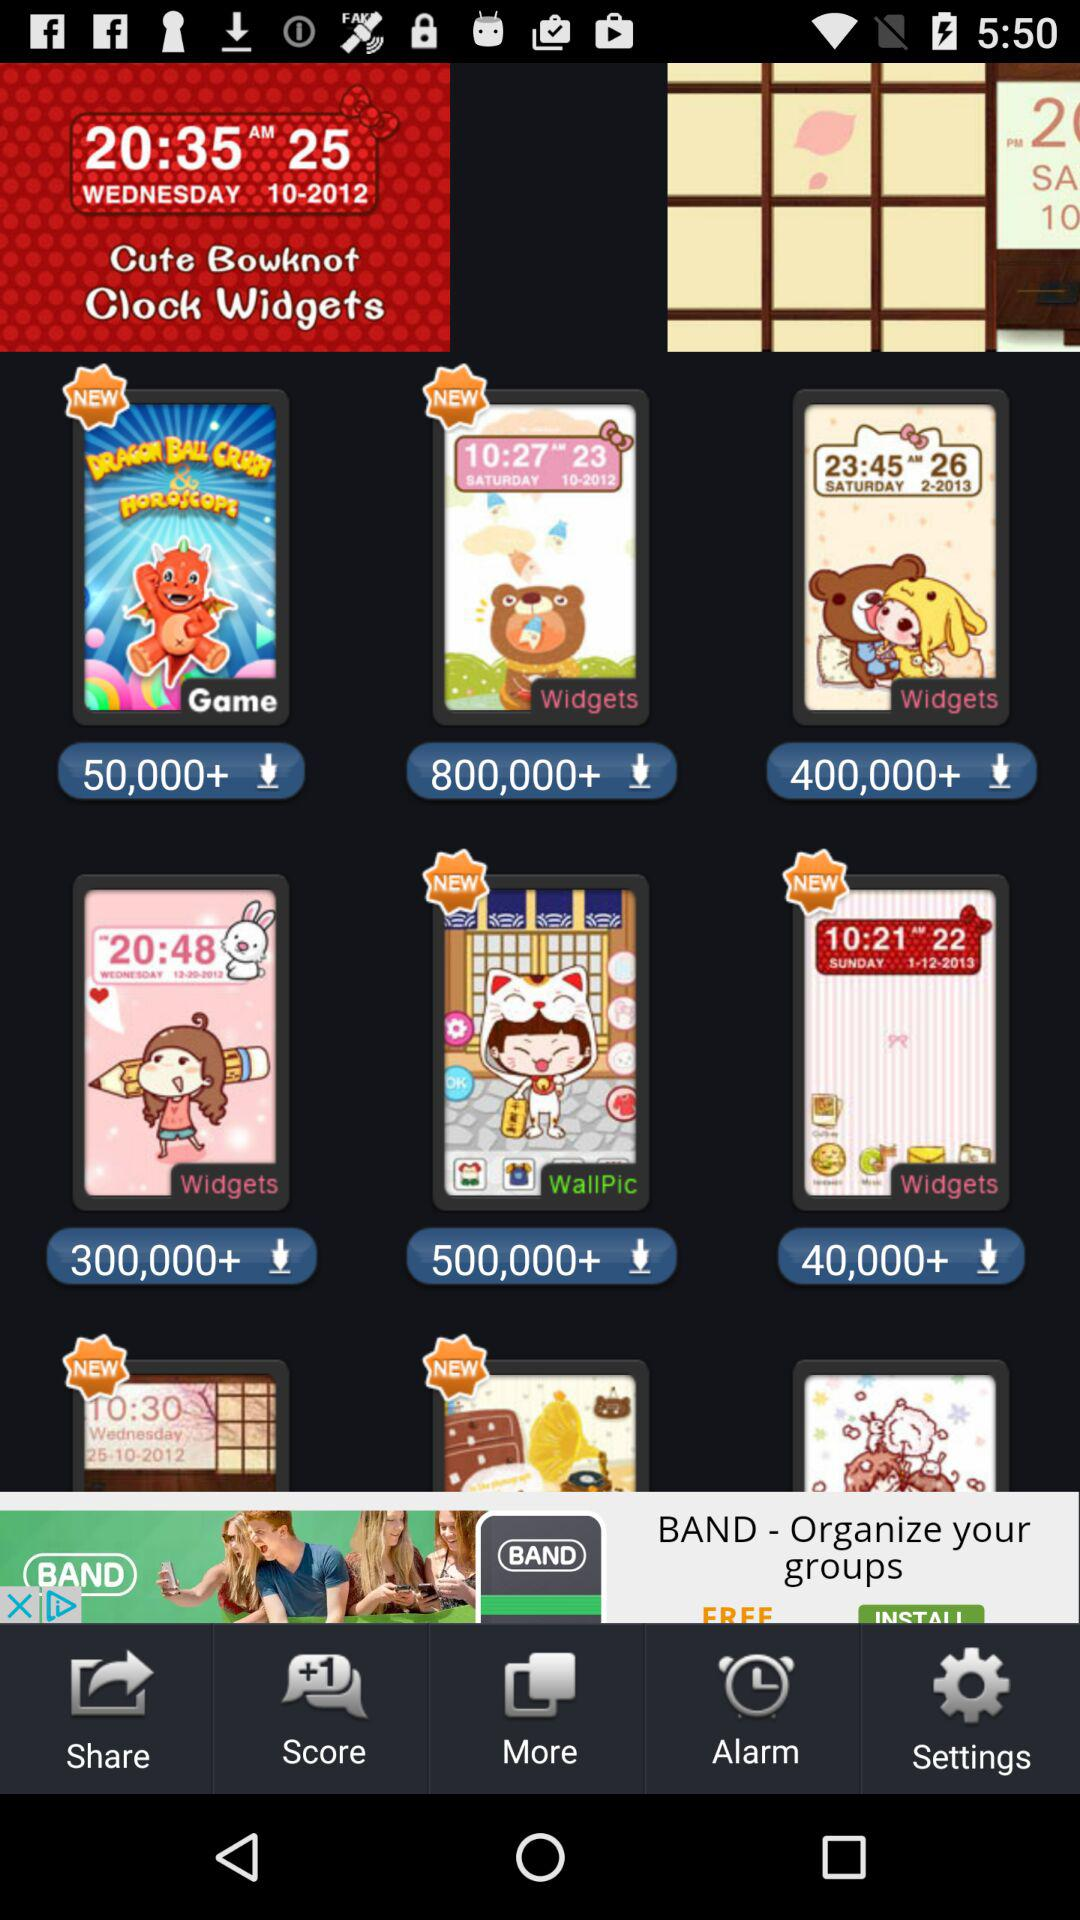What is the total number of downloads for the widget that displays the time 10:27? The total number of downloads is 800,000+. 